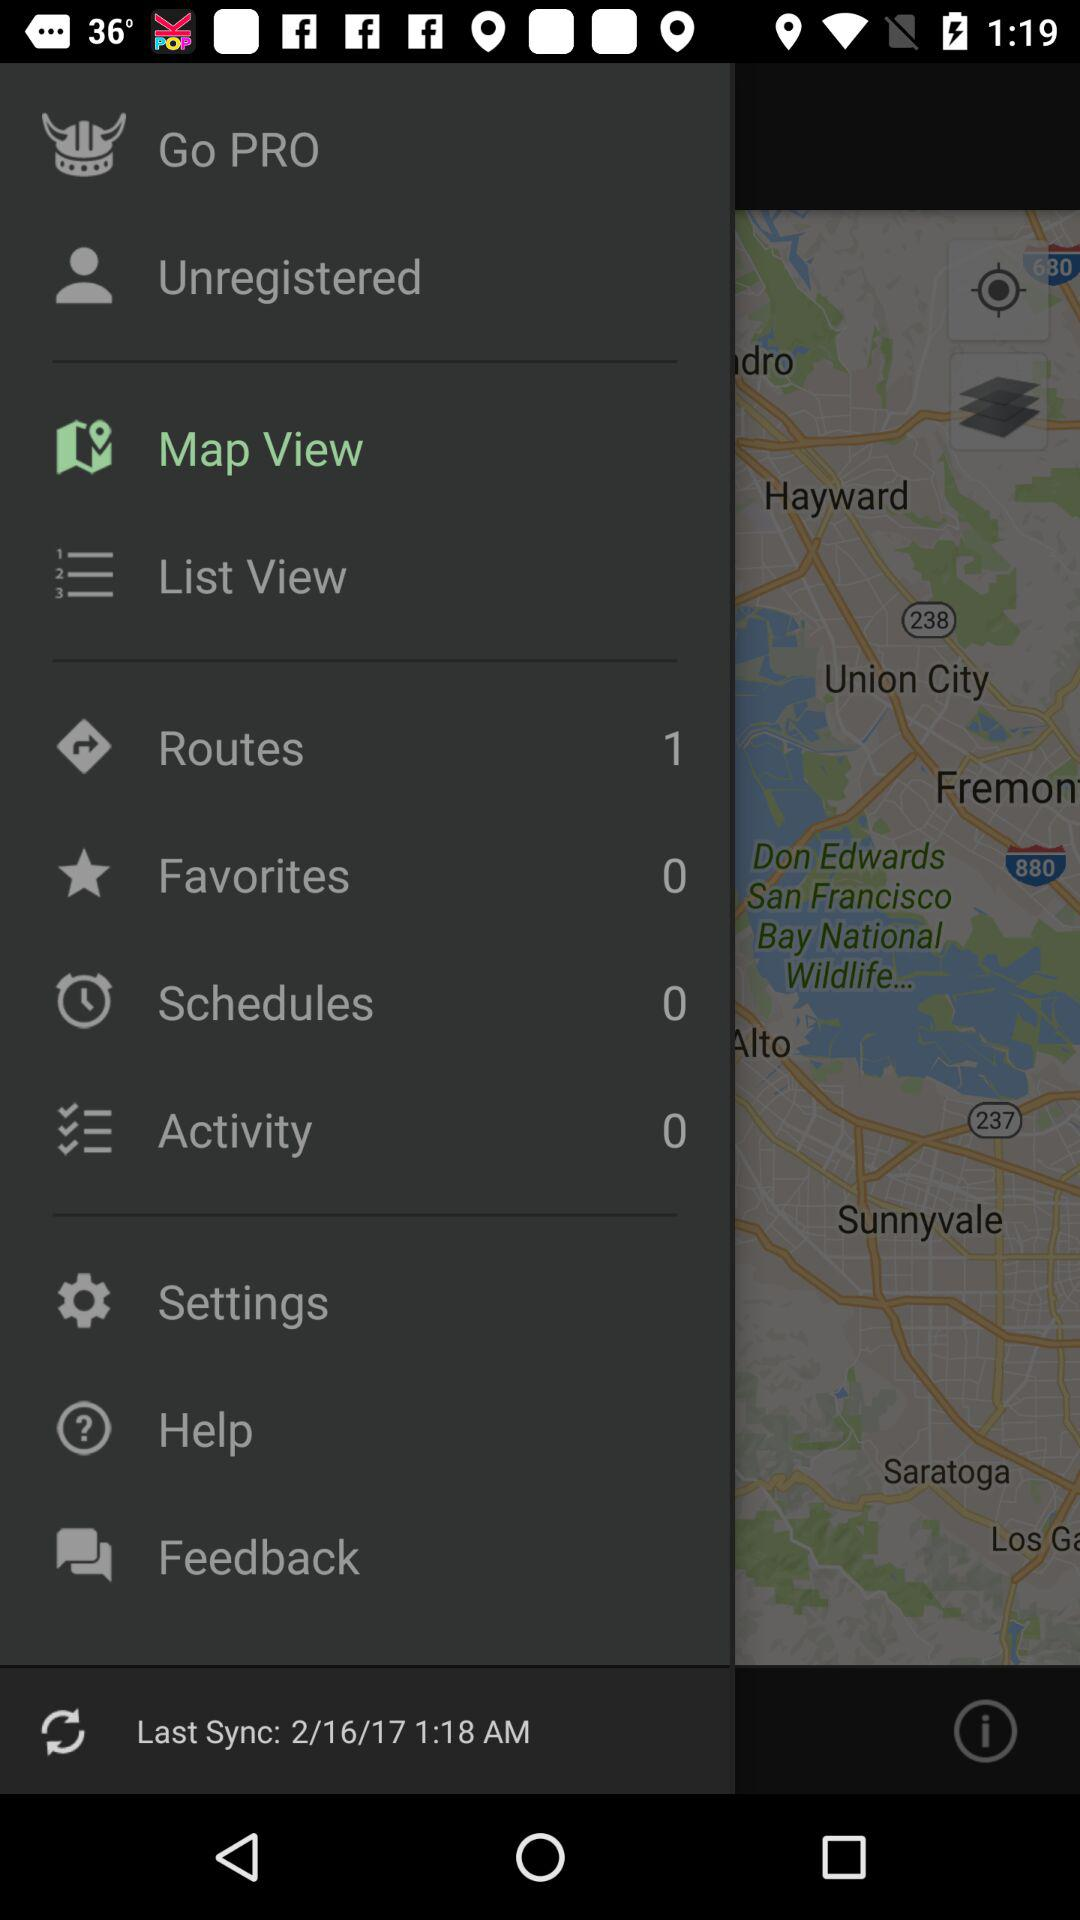What is the type of view? The types of views are "Map View" and "List View". 